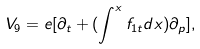Convert formula to latex. <formula><loc_0><loc_0><loc_500><loc_500>V _ { 9 } = e [ \partial _ { t } + ( \int ^ { x } f _ { 1 t } d x ) \partial _ { p } ] ,</formula> 